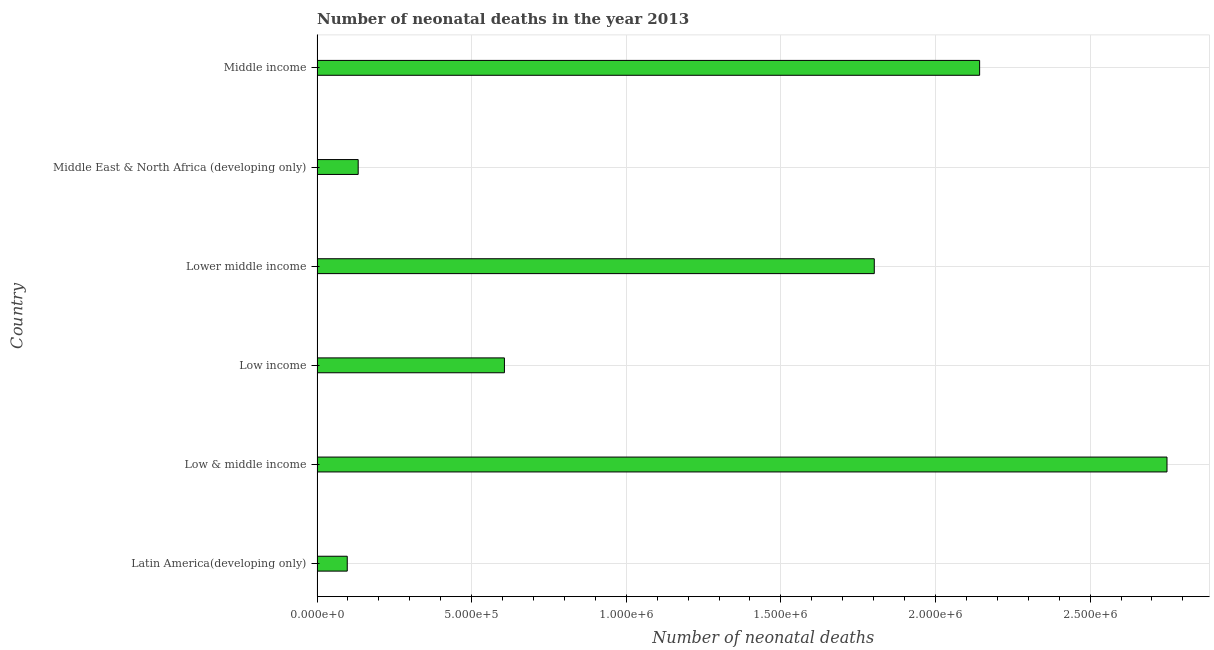Does the graph contain grids?
Give a very brief answer. Yes. What is the title of the graph?
Your response must be concise. Number of neonatal deaths in the year 2013. What is the label or title of the X-axis?
Give a very brief answer. Number of neonatal deaths. What is the label or title of the Y-axis?
Give a very brief answer. Country. What is the number of neonatal deaths in Middle income?
Offer a terse response. 2.14e+06. Across all countries, what is the maximum number of neonatal deaths?
Ensure brevity in your answer.  2.75e+06. Across all countries, what is the minimum number of neonatal deaths?
Keep it short and to the point. 9.76e+04. In which country was the number of neonatal deaths minimum?
Make the answer very short. Latin America(developing only). What is the sum of the number of neonatal deaths?
Make the answer very short. 7.53e+06. What is the difference between the number of neonatal deaths in Latin America(developing only) and Low income?
Your answer should be compact. -5.08e+05. What is the average number of neonatal deaths per country?
Give a very brief answer. 1.25e+06. What is the median number of neonatal deaths?
Your response must be concise. 1.20e+06. What is the ratio of the number of neonatal deaths in Latin America(developing only) to that in Middle East & North Africa (developing only)?
Your answer should be very brief. 0.73. Is the number of neonatal deaths in Lower middle income less than that in Middle income?
Offer a very short reply. Yes. What is the difference between the highest and the second highest number of neonatal deaths?
Offer a very short reply. 6.06e+05. What is the difference between the highest and the lowest number of neonatal deaths?
Your answer should be very brief. 2.65e+06. How many countries are there in the graph?
Your answer should be very brief. 6. What is the difference between two consecutive major ticks on the X-axis?
Give a very brief answer. 5.00e+05. What is the Number of neonatal deaths of Latin America(developing only)?
Offer a terse response. 9.76e+04. What is the Number of neonatal deaths of Low & middle income?
Make the answer very short. 2.75e+06. What is the Number of neonatal deaths in Low income?
Make the answer very short. 6.06e+05. What is the Number of neonatal deaths of Lower middle income?
Keep it short and to the point. 1.80e+06. What is the Number of neonatal deaths of Middle East & North Africa (developing only)?
Offer a terse response. 1.33e+05. What is the Number of neonatal deaths of Middle income?
Provide a short and direct response. 2.14e+06. What is the difference between the Number of neonatal deaths in Latin America(developing only) and Low & middle income?
Provide a short and direct response. -2.65e+06. What is the difference between the Number of neonatal deaths in Latin America(developing only) and Low income?
Provide a succinct answer. -5.08e+05. What is the difference between the Number of neonatal deaths in Latin America(developing only) and Lower middle income?
Make the answer very short. -1.70e+06. What is the difference between the Number of neonatal deaths in Latin America(developing only) and Middle East & North Africa (developing only)?
Your answer should be very brief. -3.54e+04. What is the difference between the Number of neonatal deaths in Latin America(developing only) and Middle income?
Make the answer very short. -2.05e+06. What is the difference between the Number of neonatal deaths in Low & middle income and Low income?
Make the answer very short. 2.14e+06. What is the difference between the Number of neonatal deaths in Low & middle income and Lower middle income?
Give a very brief answer. 9.47e+05. What is the difference between the Number of neonatal deaths in Low & middle income and Middle East & North Africa (developing only)?
Your answer should be very brief. 2.62e+06. What is the difference between the Number of neonatal deaths in Low & middle income and Middle income?
Keep it short and to the point. 6.06e+05. What is the difference between the Number of neonatal deaths in Low income and Lower middle income?
Offer a terse response. -1.20e+06. What is the difference between the Number of neonatal deaths in Low income and Middle East & North Africa (developing only)?
Your response must be concise. 4.73e+05. What is the difference between the Number of neonatal deaths in Low income and Middle income?
Your answer should be very brief. -1.54e+06. What is the difference between the Number of neonatal deaths in Lower middle income and Middle East & North Africa (developing only)?
Your response must be concise. 1.67e+06. What is the difference between the Number of neonatal deaths in Lower middle income and Middle income?
Keep it short and to the point. -3.41e+05. What is the difference between the Number of neonatal deaths in Middle East & North Africa (developing only) and Middle income?
Offer a very short reply. -2.01e+06. What is the ratio of the Number of neonatal deaths in Latin America(developing only) to that in Low & middle income?
Provide a short and direct response. 0.04. What is the ratio of the Number of neonatal deaths in Latin America(developing only) to that in Low income?
Give a very brief answer. 0.16. What is the ratio of the Number of neonatal deaths in Latin America(developing only) to that in Lower middle income?
Your answer should be very brief. 0.05. What is the ratio of the Number of neonatal deaths in Latin America(developing only) to that in Middle East & North Africa (developing only)?
Keep it short and to the point. 0.73. What is the ratio of the Number of neonatal deaths in Latin America(developing only) to that in Middle income?
Keep it short and to the point. 0.05. What is the ratio of the Number of neonatal deaths in Low & middle income to that in Low income?
Your answer should be very brief. 4.54. What is the ratio of the Number of neonatal deaths in Low & middle income to that in Lower middle income?
Your answer should be very brief. 1.52. What is the ratio of the Number of neonatal deaths in Low & middle income to that in Middle East & North Africa (developing only)?
Offer a very short reply. 20.67. What is the ratio of the Number of neonatal deaths in Low & middle income to that in Middle income?
Keep it short and to the point. 1.28. What is the ratio of the Number of neonatal deaths in Low income to that in Lower middle income?
Provide a short and direct response. 0.34. What is the ratio of the Number of neonatal deaths in Low income to that in Middle East & North Africa (developing only)?
Offer a very short reply. 4.56. What is the ratio of the Number of neonatal deaths in Low income to that in Middle income?
Provide a short and direct response. 0.28. What is the ratio of the Number of neonatal deaths in Lower middle income to that in Middle East & North Africa (developing only)?
Make the answer very short. 13.55. What is the ratio of the Number of neonatal deaths in Lower middle income to that in Middle income?
Your answer should be very brief. 0.84. What is the ratio of the Number of neonatal deaths in Middle East & North Africa (developing only) to that in Middle income?
Offer a very short reply. 0.06. 